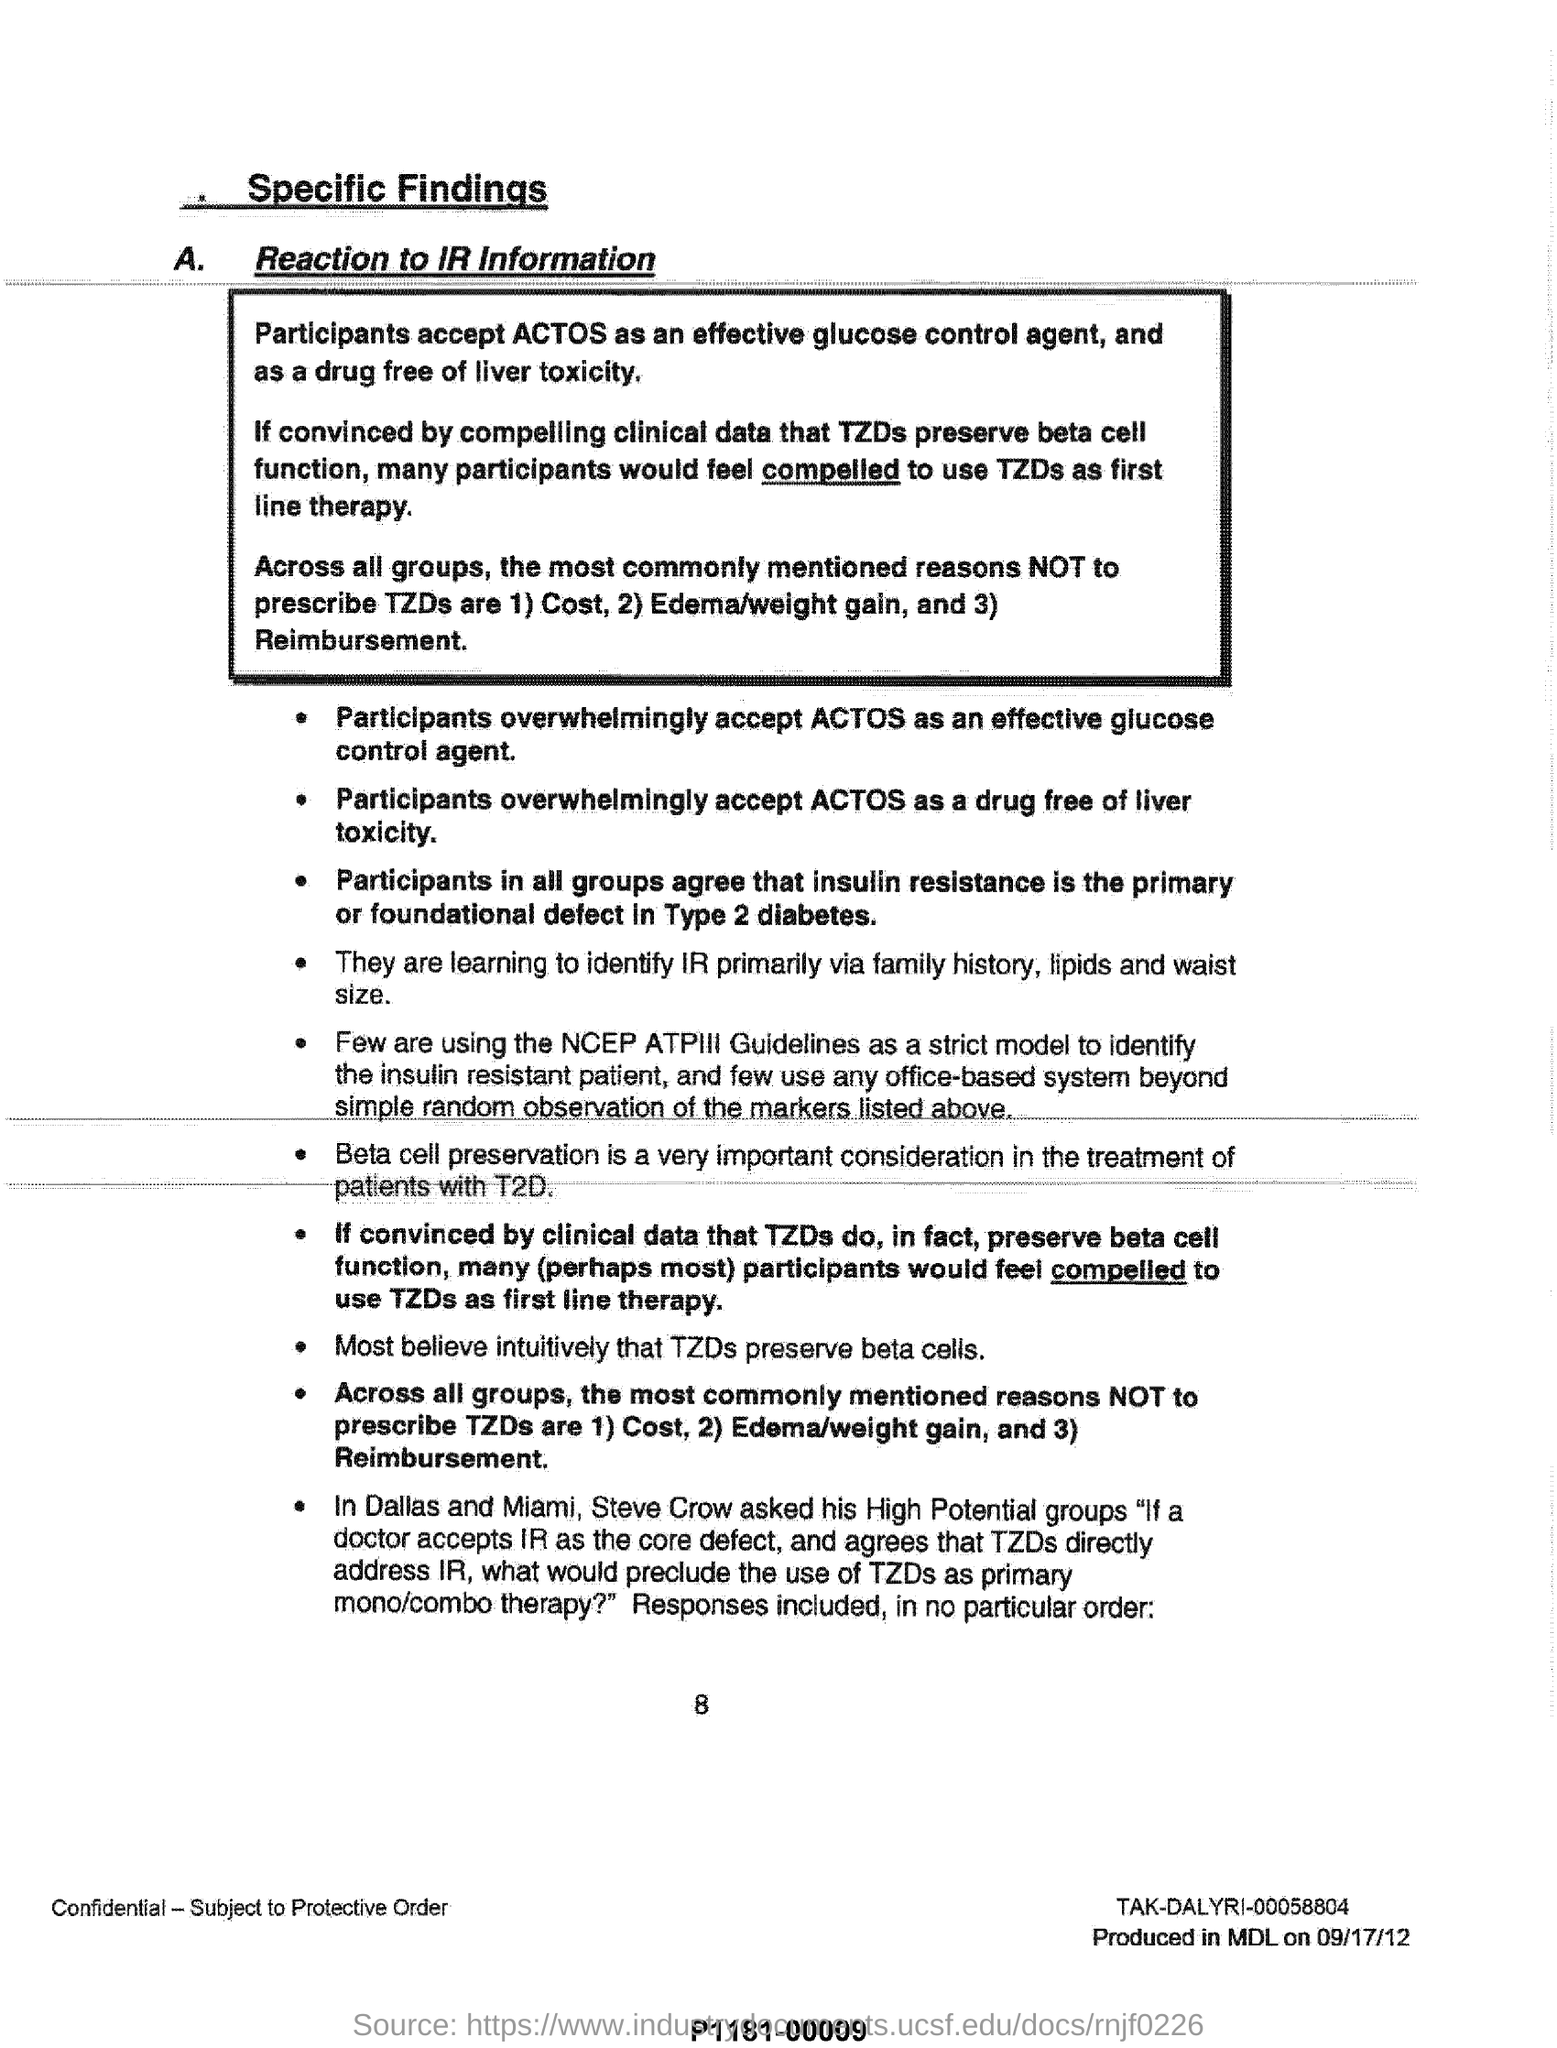What is accepted as an effective glucose control agent?
Offer a very short reply. ACTOS. What are reasons not to prescribe tzds ?
Your answer should be compact. 1)cost,2)edema/weight gain, and 3) reimbursement. What is the subheading under the title of "specific findings"?
Keep it short and to the point. A. Reaction to IR Information. 